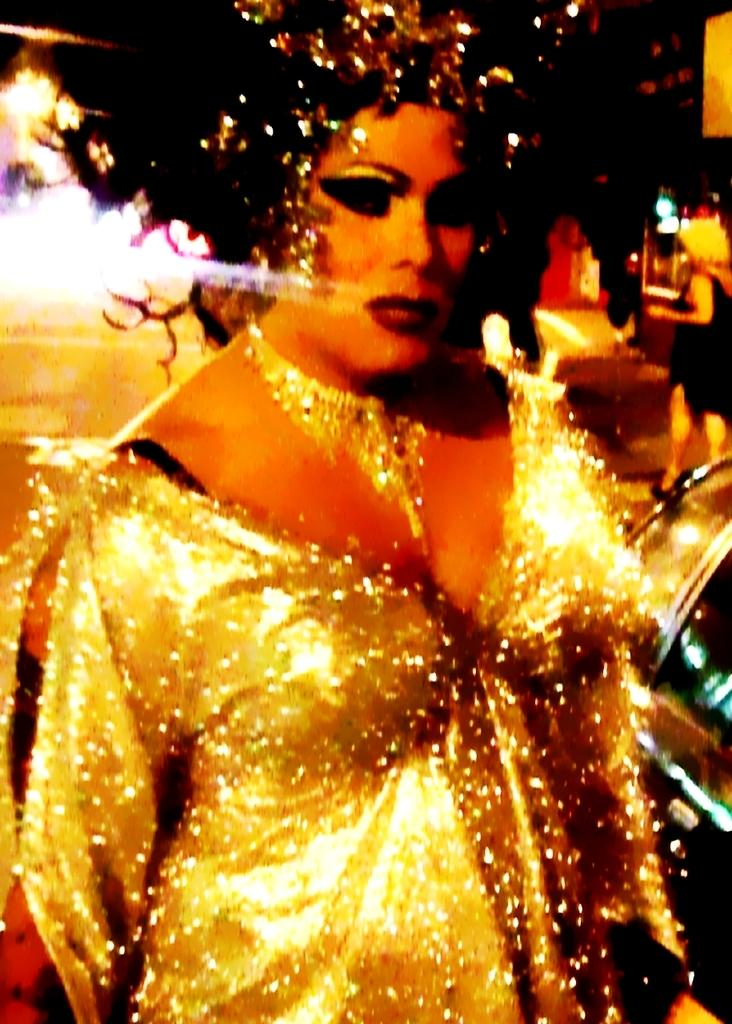Who is the main subject in the image? There is a woman standing in the center of the image. Can you describe the background of the image? There is another woman in the background of the image, and there are lights visible as well. What type of punishment is the woman in the background receiving in the image? There is no indication of punishment in the image; it simply shows two women and lights in the background. 